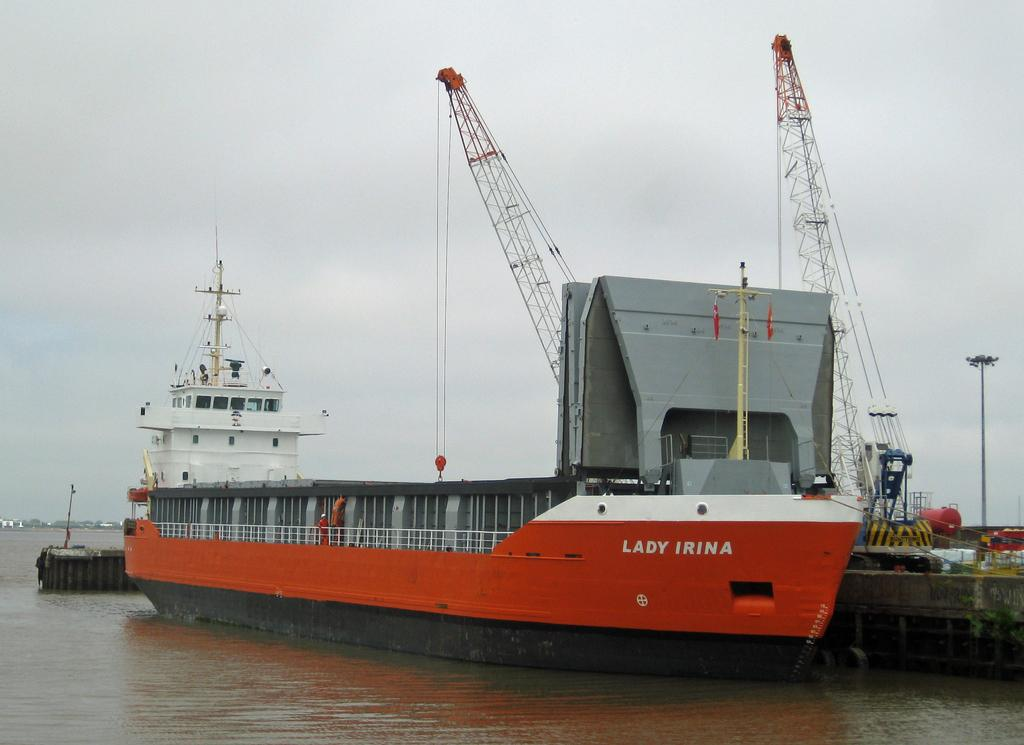<image>
Share a concise interpretation of the image provided. The ship Lady Irina sits at the dock. 